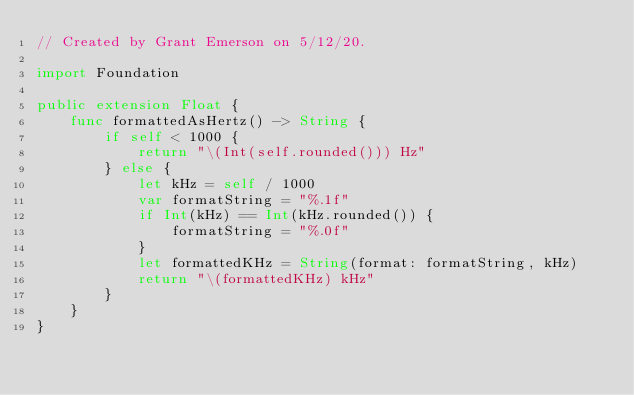<code> <loc_0><loc_0><loc_500><loc_500><_Swift_>// Created by Grant Emerson on 5/12/20.

import Foundation

public extension Float {
    func formattedAsHertz() -> String {
        if self < 1000 {
            return "\(Int(self.rounded())) Hz"
        } else {
            let kHz = self / 1000
            var formatString = "%.1f"
            if Int(kHz) == Int(kHz.rounded()) {
                formatString = "%.0f"
            }
            let formattedKHz = String(format: formatString, kHz)
            return "\(formattedKHz) kHz"
        }
    }
}
</code> 